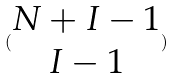Convert formula to latex. <formula><loc_0><loc_0><loc_500><loc_500>( \begin{matrix} N + I - 1 \\ I - 1 \end{matrix} )</formula> 